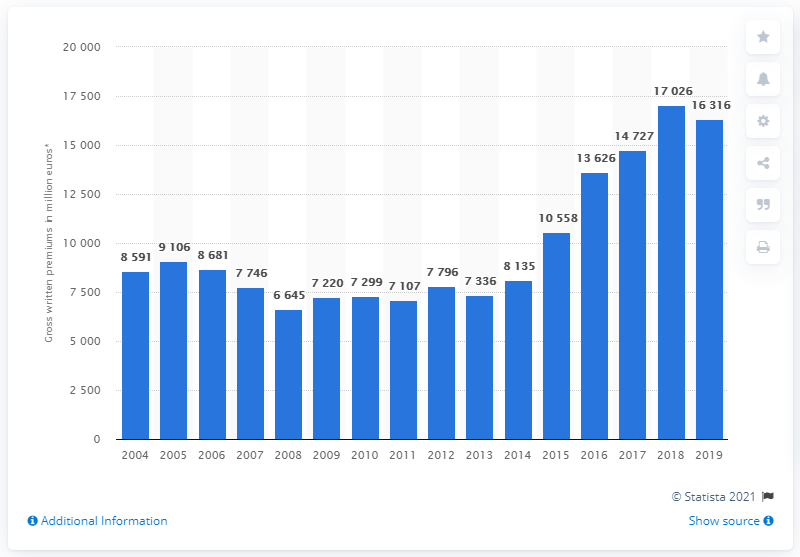Specify some key components in this picture. In 2019, the total amount of general liability insurance gross written premiums in the UK was 16,316. The amount of general liability insurance gross written premiums in the UK from 2004 to 2019 was approximately 170,260. 